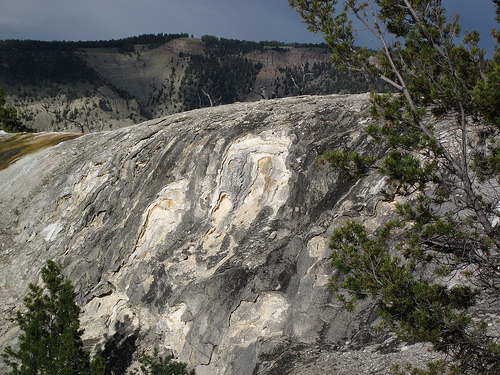<image>
Can you confirm if the tree is behind the mountain? No. The tree is not behind the mountain. From this viewpoint, the tree appears to be positioned elsewhere in the scene. 